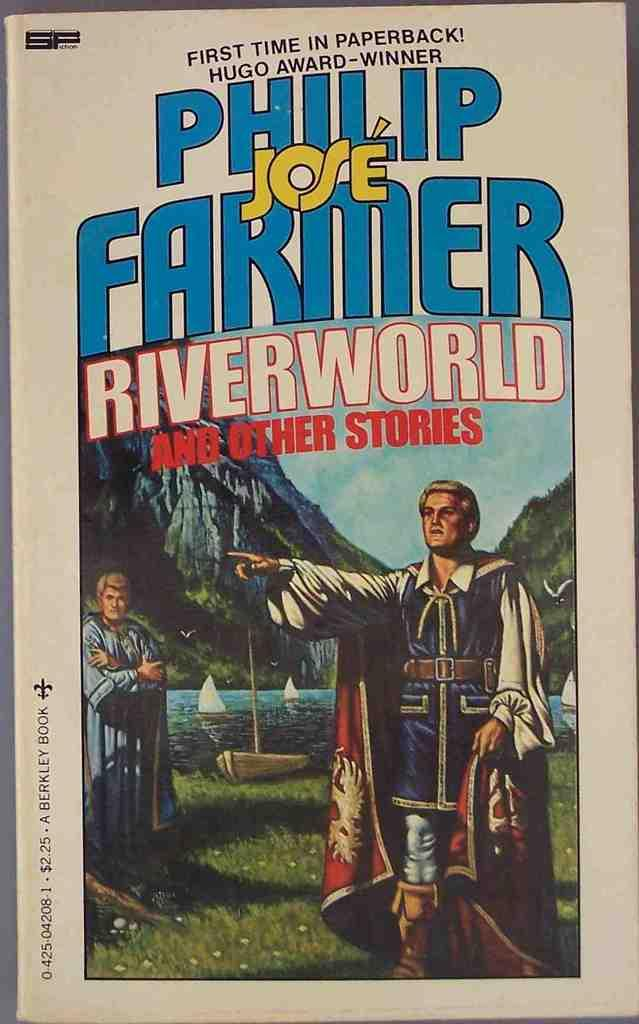<image>
Give a short and clear explanation of the subsequent image. Riverworld and Other Stories is finally available in paperback. 